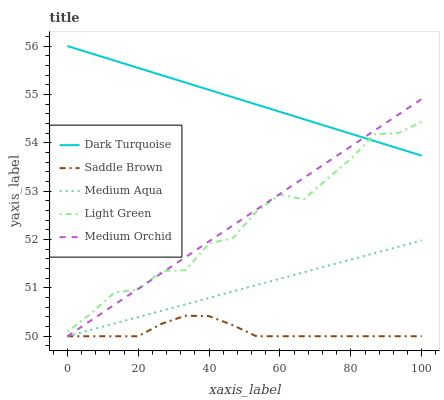Does Saddle Brown have the minimum area under the curve?
Answer yes or no. Yes. Does Dark Turquoise have the maximum area under the curve?
Answer yes or no. Yes. Does Medium Orchid have the minimum area under the curve?
Answer yes or no. No. Does Medium Orchid have the maximum area under the curve?
Answer yes or no. No. Is Medium Aqua the smoothest?
Answer yes or no. Yes. Is Light Green the roughest?
Answer yes or no. Yes. Is Medium Orchid the smoothest?
Answer yes or no. No. Is Medium Orchid the roughest?
Answer yes or no. No. Does Light Green have the lowest value?
Answer yes or no. No. Does Medium Orchid have the highest value?
Answer yes or no. No. Is Saddle Brown less than Light Green?
Answer yes or no. Yes. Is Light Green greater than Medium Aqua?
Answer yes or no. Yes. Does Saddle Brown intersect Light Green?
Answer yes or no. No. 